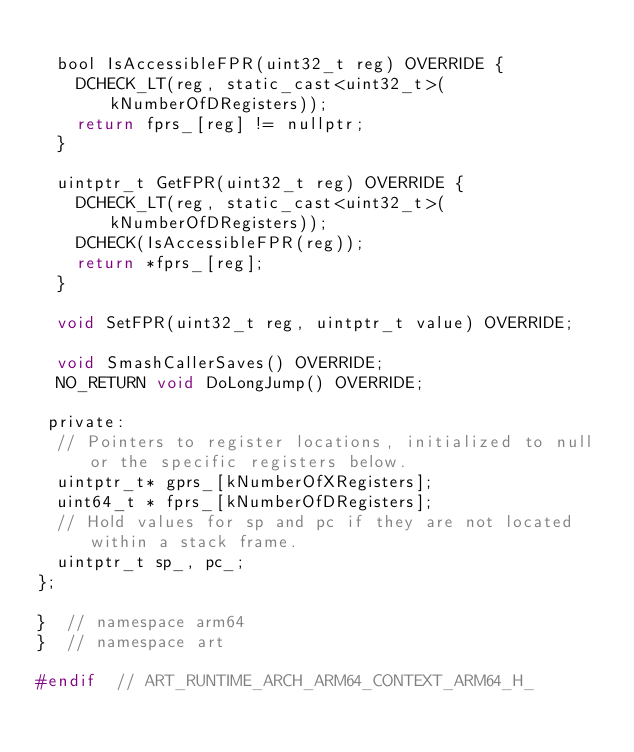Convert code to text. <code><loc_0><loc_0><loc_500><loc_500><_C_>
  bool IsAccessibleFPR(uint32_t reg) OVERRIDE {
    DCHECK_LT(reg, static_cast<uint32_t>(kNumberOfDRegisters));
    return fprs_[reg] != nullptr;
  }

  uintptr_t GetFPR(uint32_t reg) OVERRIDE {
    DCHECK_LT(reg, static_cast<uint32_t>(kNumberOfDRegisters));
    DCHECK(IsAccessibleFPR(reg));
    return *fprs_[reg];
  }

  void SetFPR(uint32_t reg, uintptr_t value) OVERRIDE;

  void SmashCallerSaves() OVERRIDE;
  NO_RETURN void DoLongJump() OVERRIDE;

 private:
  // Pointers to register locations, initialized to null or the specific registers below.
  uintptr_t* gprs_[kNumberOfXRegisters];
  uint64_t * fprs_[kNumberOfDRegisters];
  // Hold values for sp and pc if they are not located within a stack frame.
  uintptr_t sp_, pc_;
};

}  // namespace arm64
}  // namespace art

#endif  // ART_RUNTIME_ARCH_ARM64_CONTEXT_ARM64_H_
</code> 